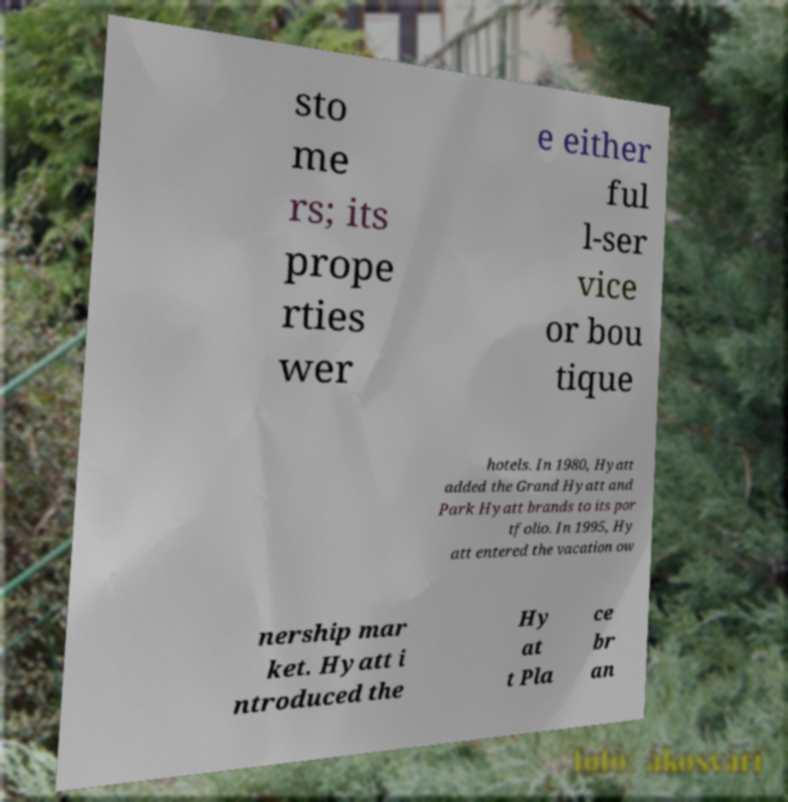Could you extract and type out the text from this image? sto me rs; its prope rties wer e either ful l-ser vice or bou tique hotels. In 1980, Hyatt added the Grand Hyatt and Park Hyatt brands to its por tfolio. In 1995, Hy att entered the vacation ow nership mar ket. Hyatt i ntroduced the Hy at t Pla ce br an 